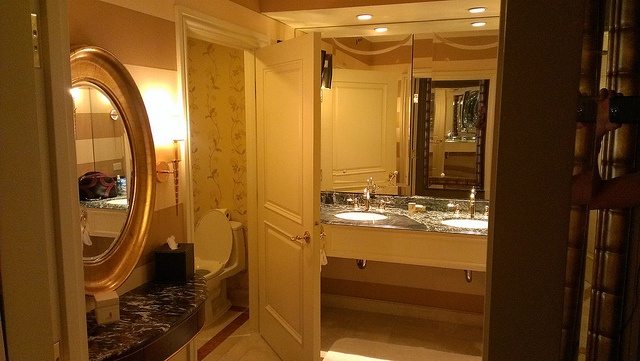Describe the objects in this image and their specific colors. I can see toilet in maroon and olive tones, handbag in maroon, black, and brown tones, sink in maroon, white, and tan tones, and sink in maroon, ivory, tan, and gray tones in this image. 